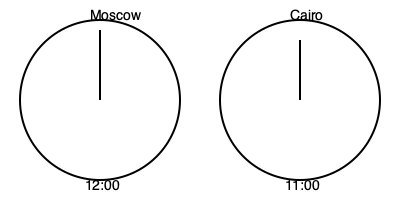As an experienced backpacker who has lived in both Russia and Arabic-speaking countries, you're organizing a video call between friends in Moscow and Cairo. Given the clock face diagrams showing the current time in both cities, calculate the time difference between Moscow and Cairo. Express your answer as a single number representing the hours Moscow is ahead of Cairo. To calculate the time difference between Moscow and Cairo, we can follow these steps:

1. Observe the clock faces:
   - Moscow's clock shows 12:00
   - Cairo's clock shows 11:00

2. Compare the two times:
   - Moscow's time is 1 hour ahead of Cairo's time

3. Determine the direction of the time difference:
   - Since Moscow's time is ahead, we express the difference as a positive number

4. Express the result:
   - Moscow is 1 hour ahead of Cairo

The time difference remains constant throughout the day due to the fixed positions of the time zones. This knowledge is particularly useful for travelers and backpackers coordinating activities across these regions.
Answer: 1 